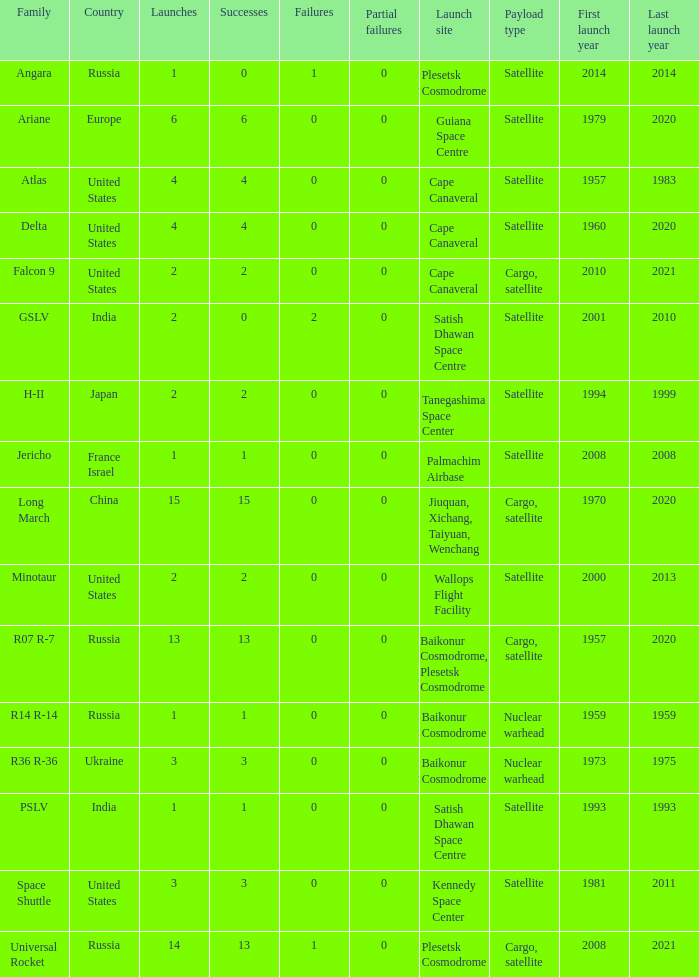What is the number of failure for the country of Russia, and a Family of r14 r-14, and a Partial failures smaller than 0? 0.0. 